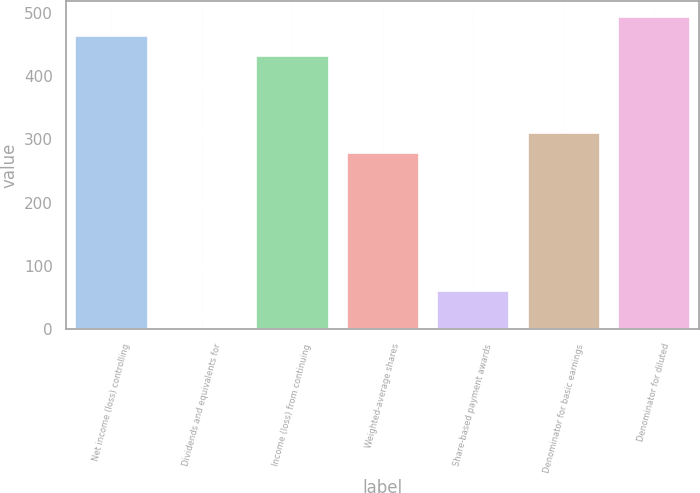Convert chart to OTSL. <chart><loc_0><loc_0><loc_500><loc_500><bar_chart><fcel>Net income (loss) controlling<fcel>Dividends and equivalents for<fcel>Income (loss) from continuing<fcel>Weighted-average shares<fcel>Share-based payment awards<fcel>Denominator for basic earnings<fcel>Denominator for diluted<nl><fcel>462.48<fcel>0.1<fcel>431.95<fcel>279.3<fcel>61.16<fcel>309.83<fcel>493.01<nl></chart> 